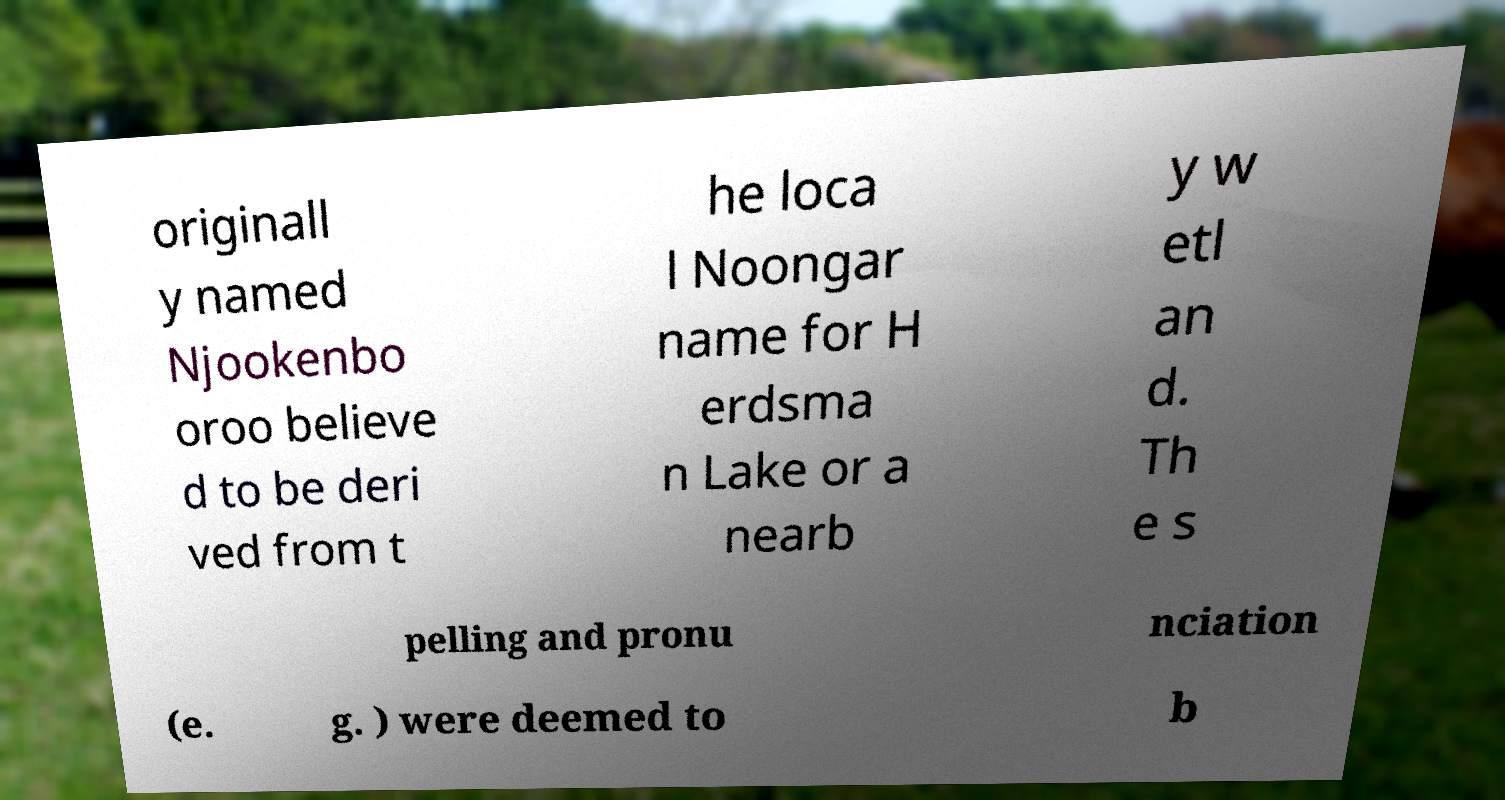For documentation purposes, I need the text within this image transcribed. Could you provide that? originall y named Njookenbo oroo believe d to be deri ved from t he loca l Noongar name for H erdsma n Lake or a nearb y w etl an d. Th e s pelling and pronu nciation (e. g. ) were deemed to b 